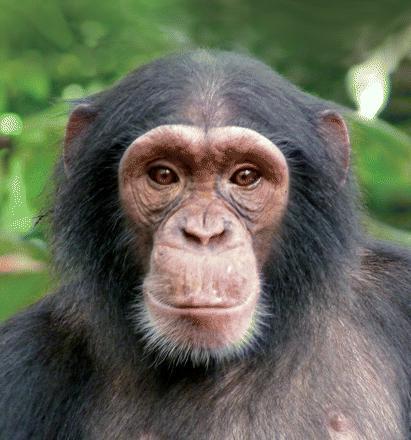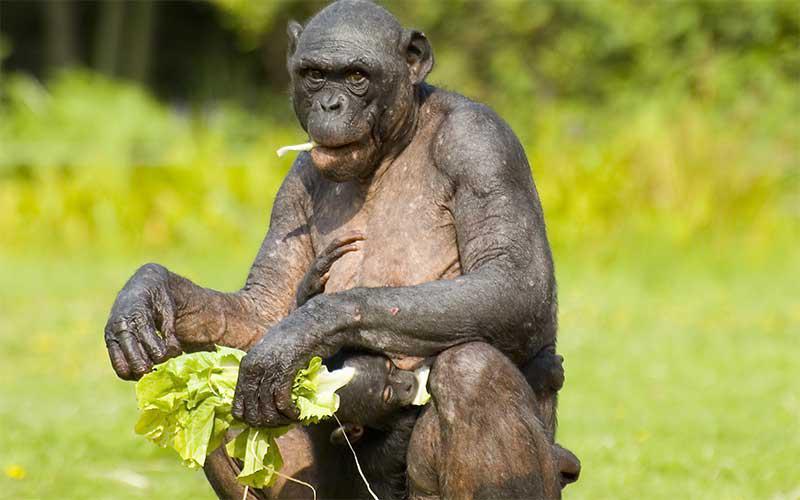The first image is the image on the left, the second image is the image on the right. Given the left and right images, does the statement "An image shows one or more young chimps with hand raised at least at head level." hold true? Answer yes or no. No. 